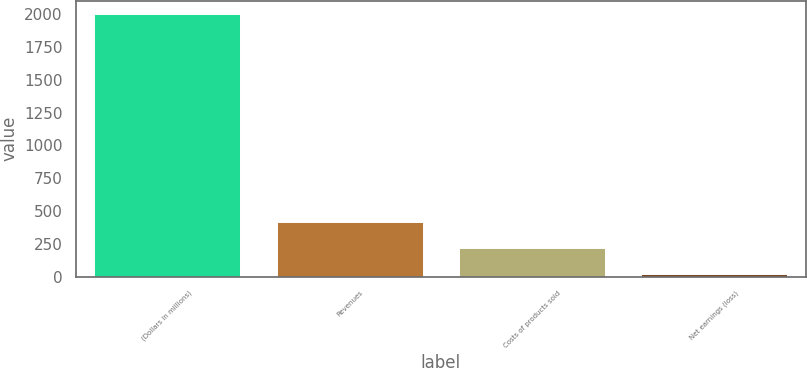<chart> <loc_0><loc_0><loc_500><loc_500><bar_chart><fcel>(Dollars in millions)<fcel>Revenues<fcel>Costs of products sold<fcel>Net earnings (loss)<nl><fcel>2003<fcel>419<fcel>221<fcel>23<nl></chart> 